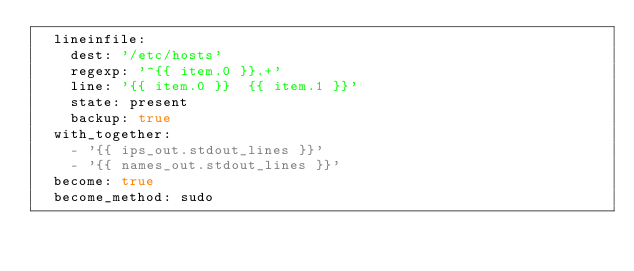<code> <loc_0><loc_0><loc_500><loc_500><_YAML_>  lineinfile:
    dest: '/etc/hosts'
    regexp: '^{{ item.0 }}.+' 
    line: '{{ item.0 }}  {{ item.1 }}'
    state: present
    backup: true
  with_together: 
    - '{{ ips_out.stdout_lines }}'    
    - '{{ names_out.stdout_lines }}'
  become: true
  become_method: sudo
  </code> 